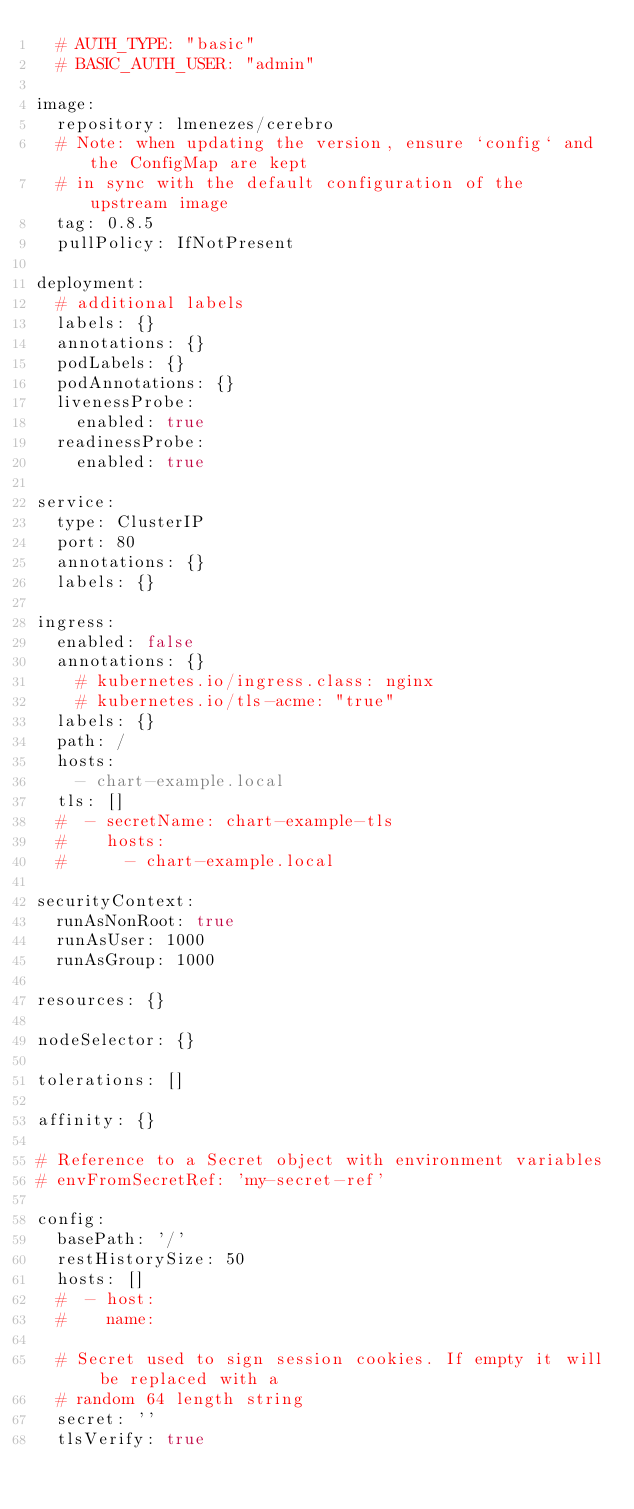<code> <loc_0><loc_0><loc_500><loc_500><_YAML_>  # AUTH_TYPE: "basic"
  # BASIC_AUTH_USER: "admin"

image:
  repository: lmenezes/cerebro
  # Note: when updating the version, ensure `config` and the ConfigMap are kept
  # in sync with the default configuration of the upstream image
  tag: 0.8.5
  pullPolicy: IfNotPresent

deployment:
  # additional labels
  labels: {}
  annotations: {}
  podLabels: {}
  podAnnotations: {}
  livenessProbe:
    enabled: true
  readinessProbe:
    enabled: true

service:
  type: ClusterIP
  port: 80
  annotations: {}
  labels: {}

ingress:
  enabled: false
  annotations: {}
    # kubernetes.io/ingress.class: nginx
    # kubernetes.io/tls-acme: "true"
  labels: {}
  path: /
  hosts:
    - chart-example.local
  tls: []
  #  - secretName: chart-example-tls
  #    hosts:
  #      - chart-example.local

securityContext:
  runAsNonRoot: true
  runAsUser: 1000
  runAsGroup: 1000

resources: {}

nodeSelector: {}

tolerations: []

affinity: {}

# Reference to a Secret object with environment variables
# envFromSecretRef: 'my-secret-ref'

config:
  basePath: '/'
  restHistorySize: 50
  hosts: []
  #  - host:
  #    name:

  # Secret used to sign session cookies. If empty it will be replaced with a
  # random 64 length string
  secret: ''
  tlsVerify: true
</code> 